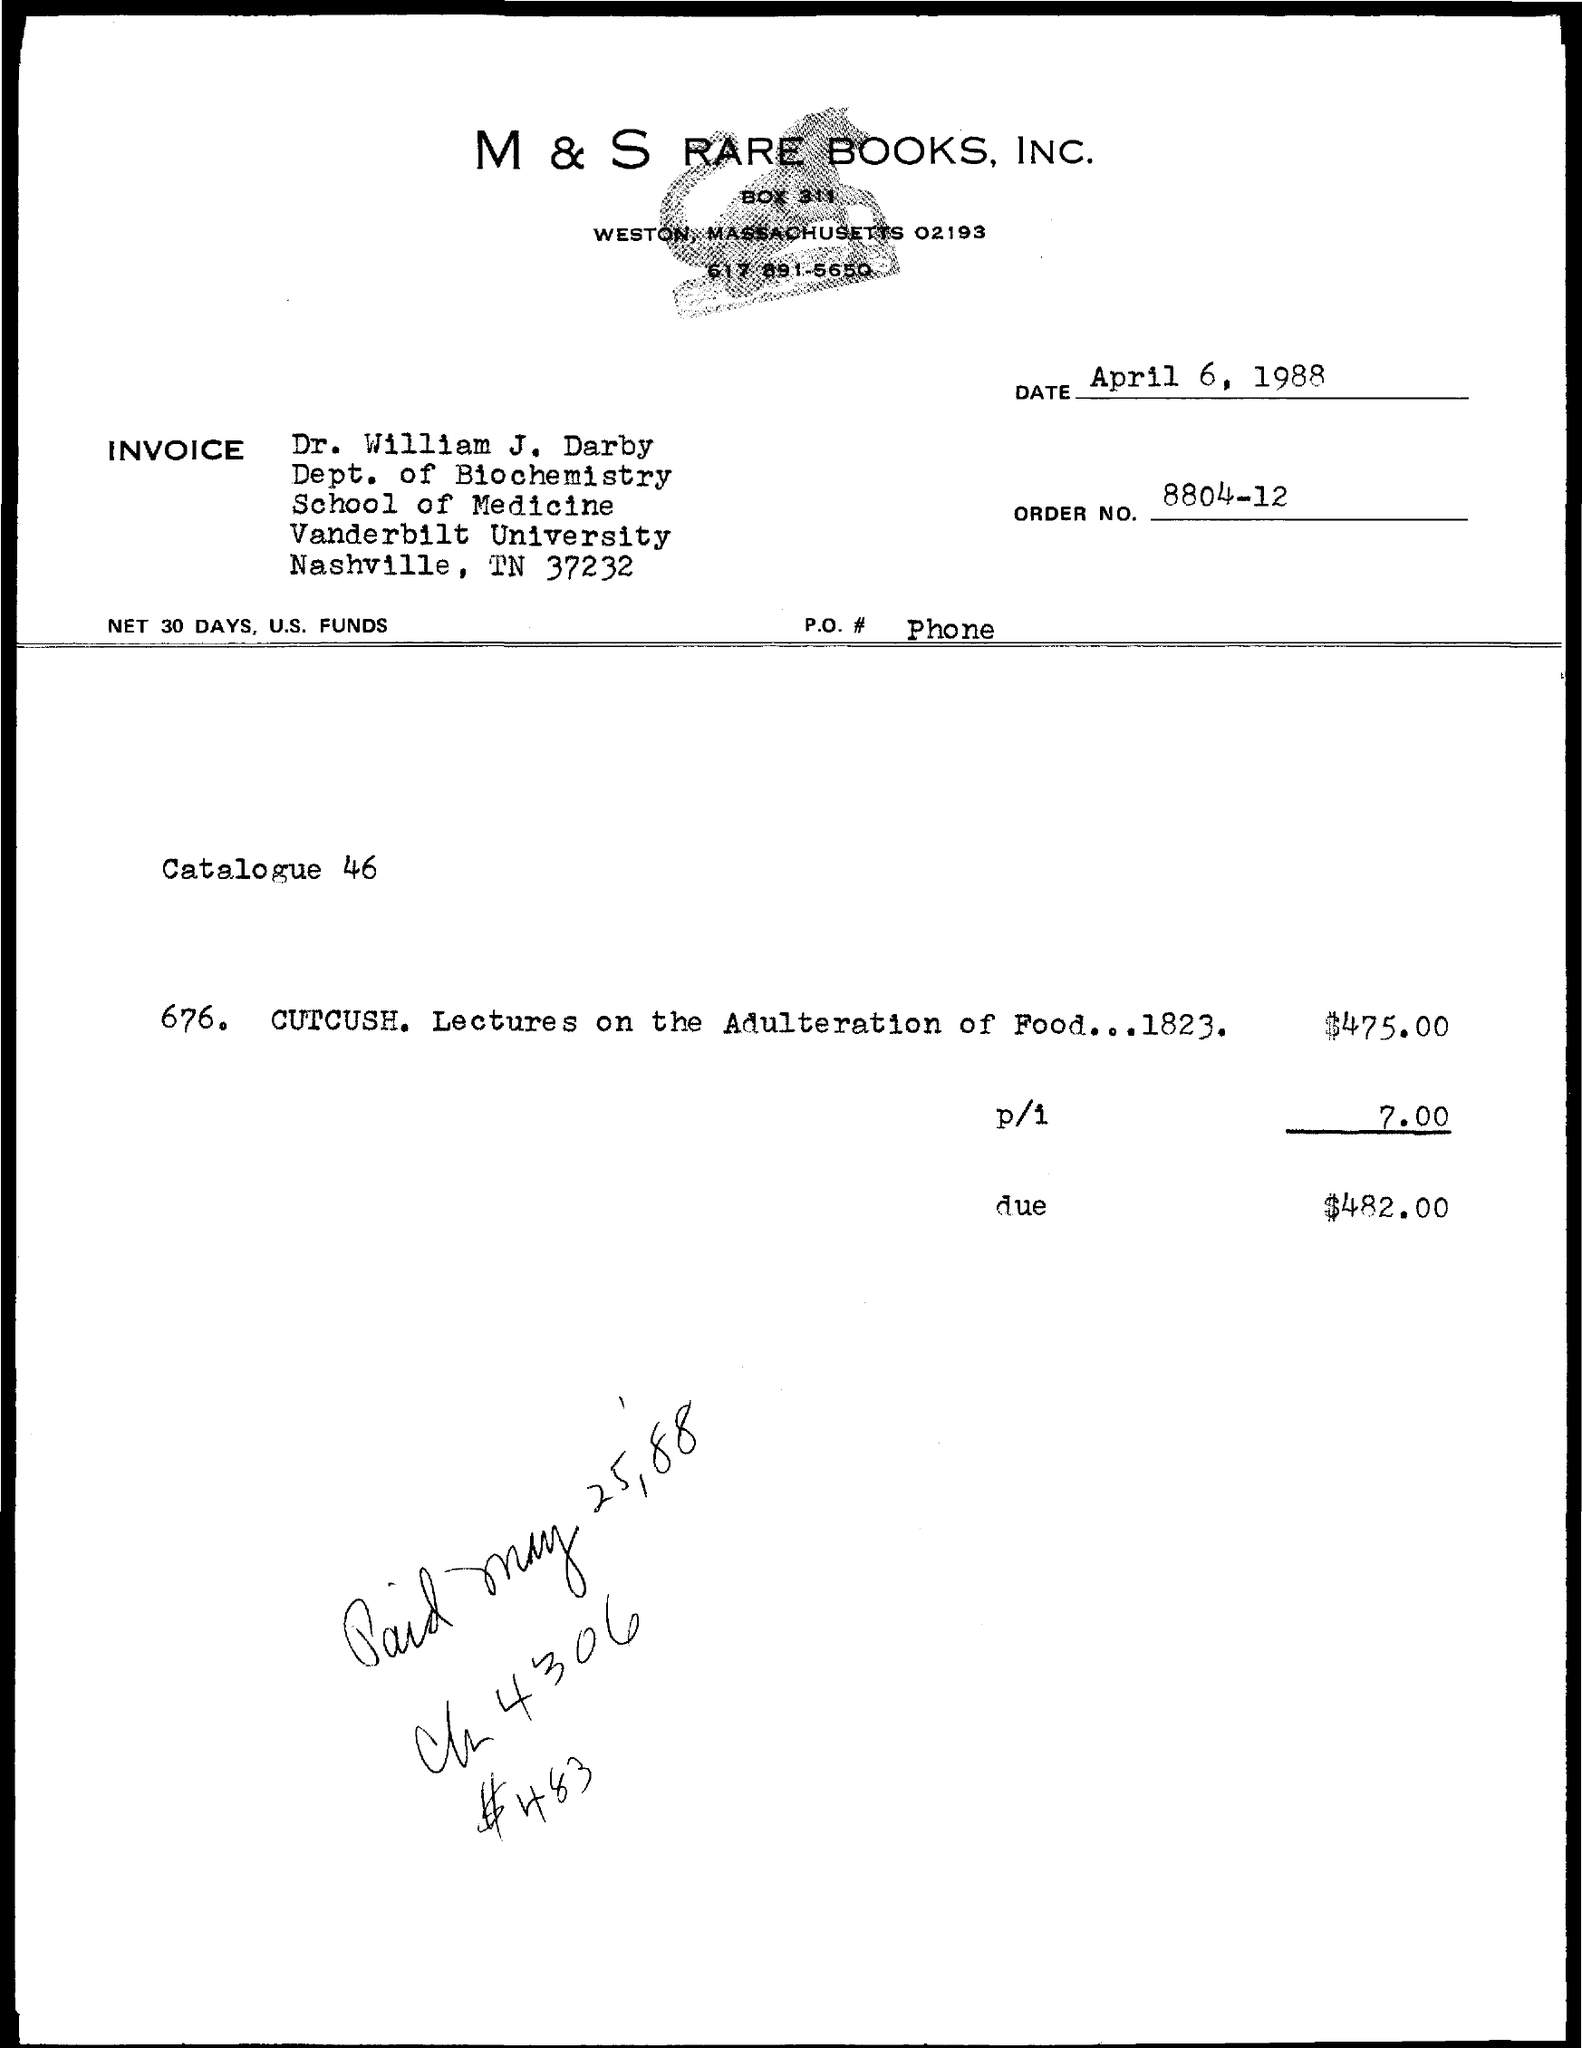Identify some key points in this picture. The amount due as per the invoice given is $482.00. Dr. William J. Darby works at Vanderbilt University. The invoice is directed to Dr. William J. Darby. The issued date of the invoice is April 6, 1988. M & S RARE BOOKS, INC. is mentioned in the header of the document. 